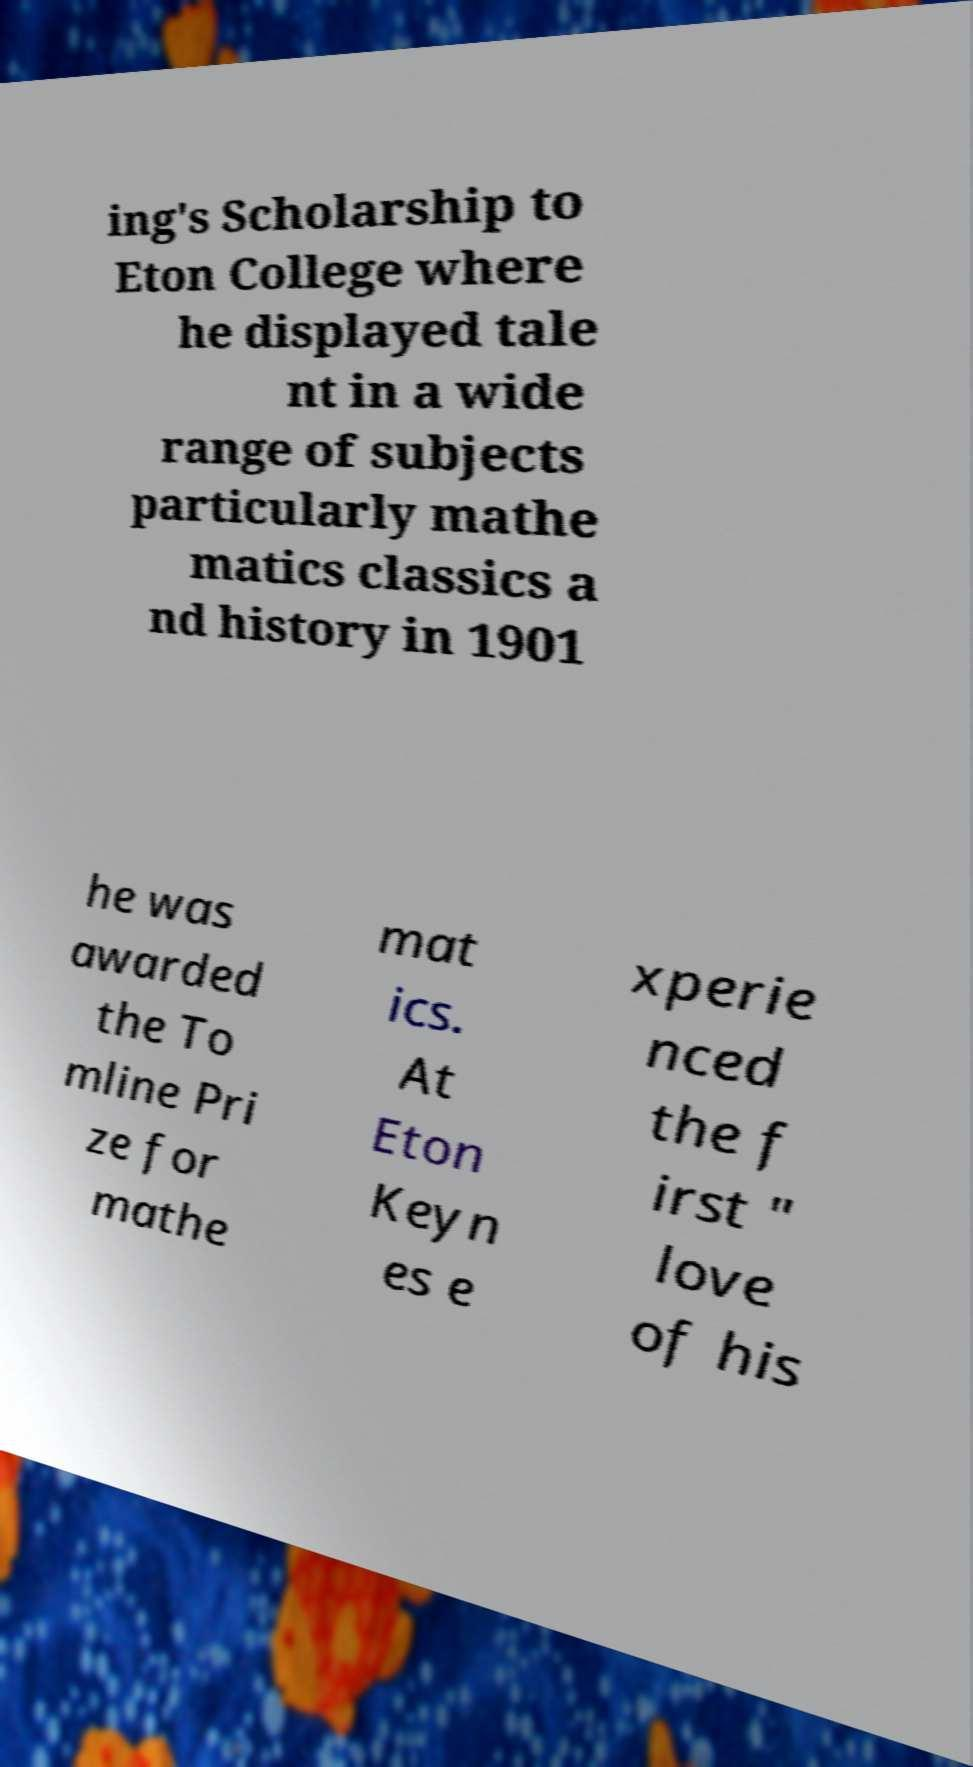Please identify and transcribe the text found in this image. ing's Scholarship to Eton College where he displayed tale nt in a wide range of subjects particularly mathe matics classics a nd history in 1901 he was awarded the To mline Pri ze for mathe mat ics. At Eton Keyn es e xperie nced the f irst " love of his 